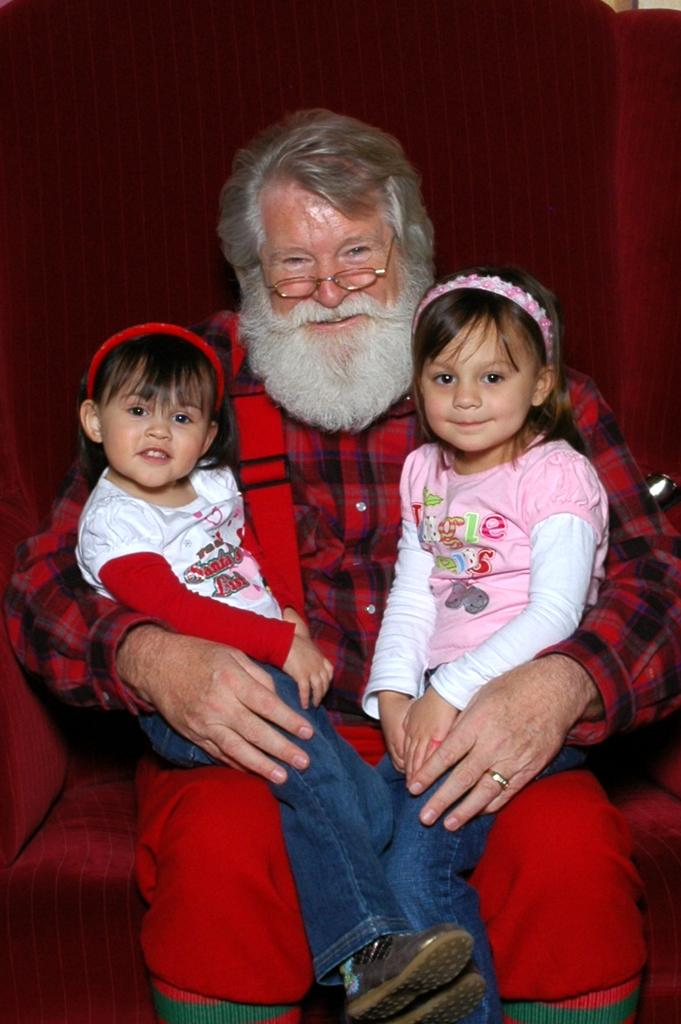Who is the main subject in the image? There is an old man in the image. What is the old man doing in the image? The old man is sitting on a red chair. Are there any other people in the image? Yes, there are two kids in the image. What are the kids doing in the image? The kids are sitting on the old man's lap. How are the kids feeling in the image? The kids are smiling. What type of root can be seen growing from the old man's hat in the image? There is no hat or root present in the image. How does the rail contribute to the scene in the image? There is no rail present in the image. 